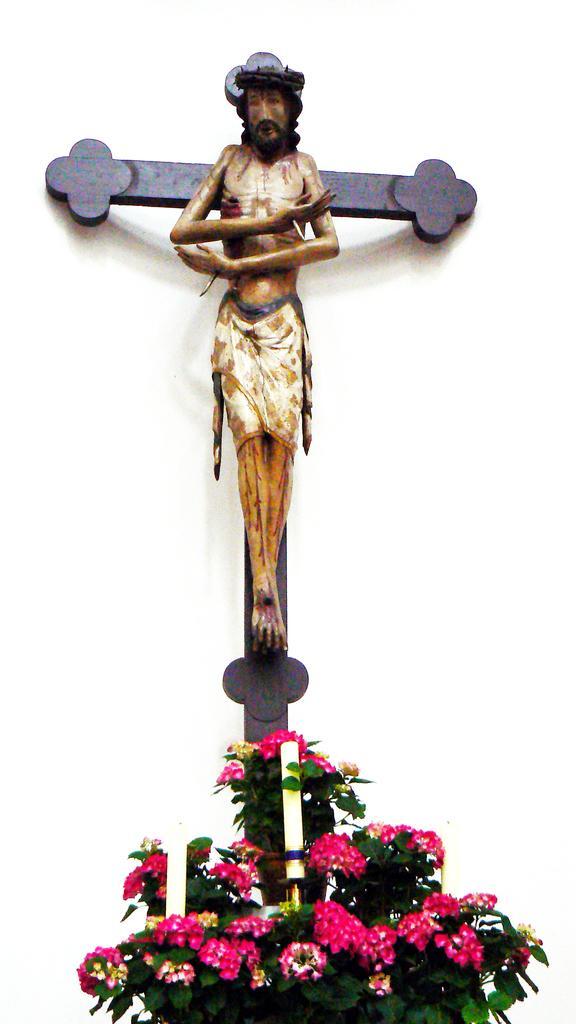Please provide a concise description of this image. In the picture I can see a statue of the Jesus. Here I can see red color flowers. The background of the image is white in color. 